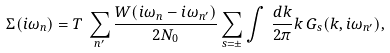Convert formula to latex. <formula><loc_0><loc_0><loc_500><loc_500>\Sigma ( i \omega _ { n } ) = T \, \sum _ { n ^ { \prime } } \frac { W ( i \omega _ { n } - i \omega _ { n ^ { \prime } } ) } { 2 N _ { 0 } } \sum _ { s = \pm } \int \, \frac { d k } { 2 \pi } k \, G _ { s } ( k , i \omega _ { n ^ { \prime } } ) ,</formula> 